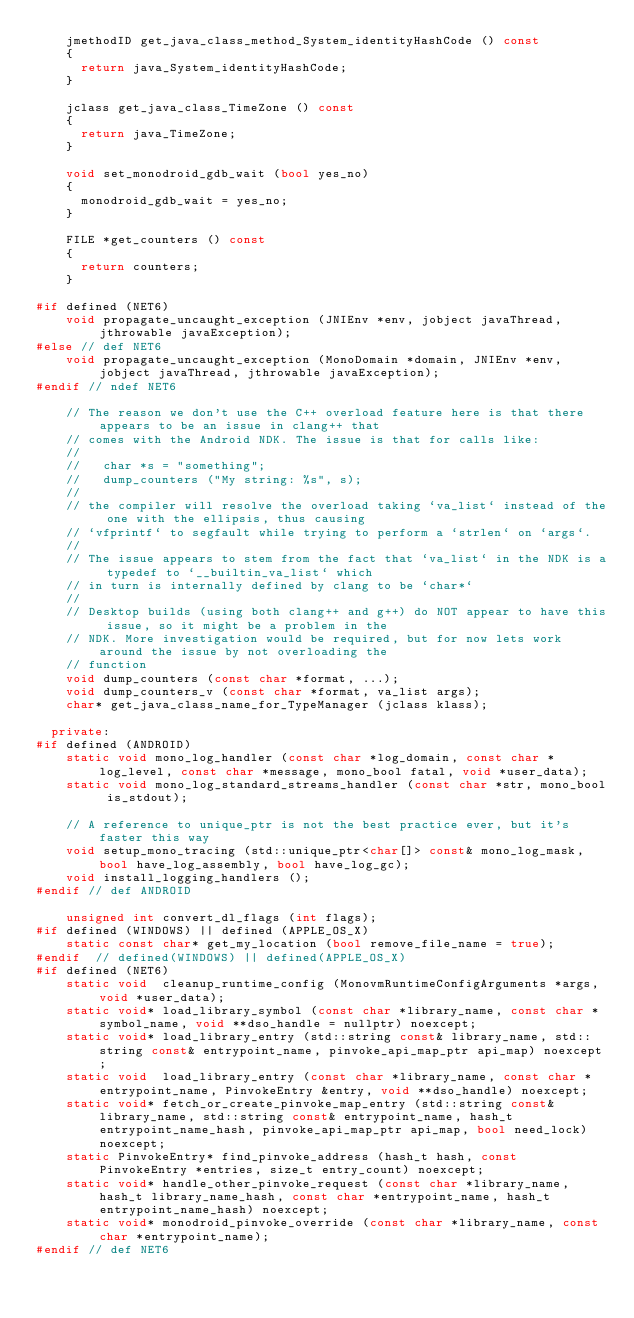Convert code to text. <code><loc_0><loc_0><loc_500><loc_500><_C++_>		jmethodID get_java_class_method_System_identityHashCode () const
		{
			return java_System_identityHashCode;
		}

		jclass get_java_class_TimeZone () const
		{
			return java_TimeZone;
		}

		void set_monodroid_gdb_wait (bool yes_no)
		{
			monodroid_gdb_wait = yes_no;
		}

		FILE *get_counters () const
		{
			return counters;
		}

#if defined (NET6)
		void propagate_uncaught_exception (JNIEnv *env, jobject javaThread, jthrowable javaException);
#else // def NET6
		void propagate_uncaught_exception (MonoDomain *domain, JNIEnv *env, jobject javaThread, jthrowable javaException);
#endif // ndef NET6

		// The reason we don't use the C++ overload feature here is that there appears to be an issue in clang++ that
		// comes with the Android NDK. The issue is that for calls like:
		//
		//   char *s = "something";
		//   dump_counters ("My string: %s", s);
		//
		// the compiler will resolve the overload taking `va_list` instead of the one with the ellipsis, thus causing
		// `vfprintf` to segfault while trying to perform a `strlen` on `args`.
		//
		// The issue appears to stem from the fact that `va_list` in the NDK is a typedef to `__builtin_va_list` which
		// in turn is internally defined by clang to be `char*`
		//
		// Desktop builds (using both clang++ and g++) do NOT appear to have this issue, so it might be a problem in the
		// NDK. More investigation would be required, but for now lets work around the issue by not overloading the
		// function
		void dump_counters (const char *format, ...);
		void dump_counters_v (const char *format, va_list args);
		char*	get_java_class_name_for_TypeManager (jclass klass);

	private:
#if defined (ANDROID)
		static void mono_log_handler (const char *log_domain, const char *log_level, const char *message, mono_bool fatal, void *user_data);
		static void mono_log_standard_streams_handler (const char *str, mono_bool is_stdout);

		// A reference to unique_ptr is not the best practice ever, but it's faster this way
		void setup_mono_tracing (std::unique_ptr<char[]> const& mono_log_mask, bool have_log_assembly, bool have_log_gc);
		void install_logging_handlers ();
#endif // def ANDROID

		unsigned int convert_dl_flags (int flags);
#if defined (WINDOWS) || defined (APPLE_OS_X)
		static const char* get_my_location (bool remove_file_name = true);
#endif  // defined(WINDOWS) || defined(APPLE_OS_X)
#if defined (NET6)
		static void  cleanup_runtime_config (MonovmRuntimeConfigArguments *args, void *user_data);
		static void* load_library_symbol (const char *library_name, const char *symbol_name, void **dso_handle = nullptr) noexcept;
		static void* load_library_entry (std::string const& library_name, std::string const& entrypoint_name, pinvoke_api_map_ptr api_map) noexcept;
		static void  load_library_entry (const char *library_name, const char *entrypoint_name, PinvokeEntry &entry, void **dso_handle) noexcept;
		static void* fetch_or_create_pinvoke_map_entry (std::string const& library_name, std::string const& entrypoint_name, hash_t entrypoint_name_hash, pinvoke_api_map_ptr api_map, bool need_lock) noexcept;
		static PinvokeEntry* find_pinvoke_address (hash_t hash, const PinvokeEntry *entries, size_t entry_count) noexcept;
		static void* handle_other_pinvoke_request (const char *library_name, hash_t library_name_hash, const char *entrypoint_name, hash_t entrypoint_name_hash) noexcept;
		static void* monodroid_pinvoke_override (const char *library_name, const char *entrypoint_name);
#endif // def NET6</code> 